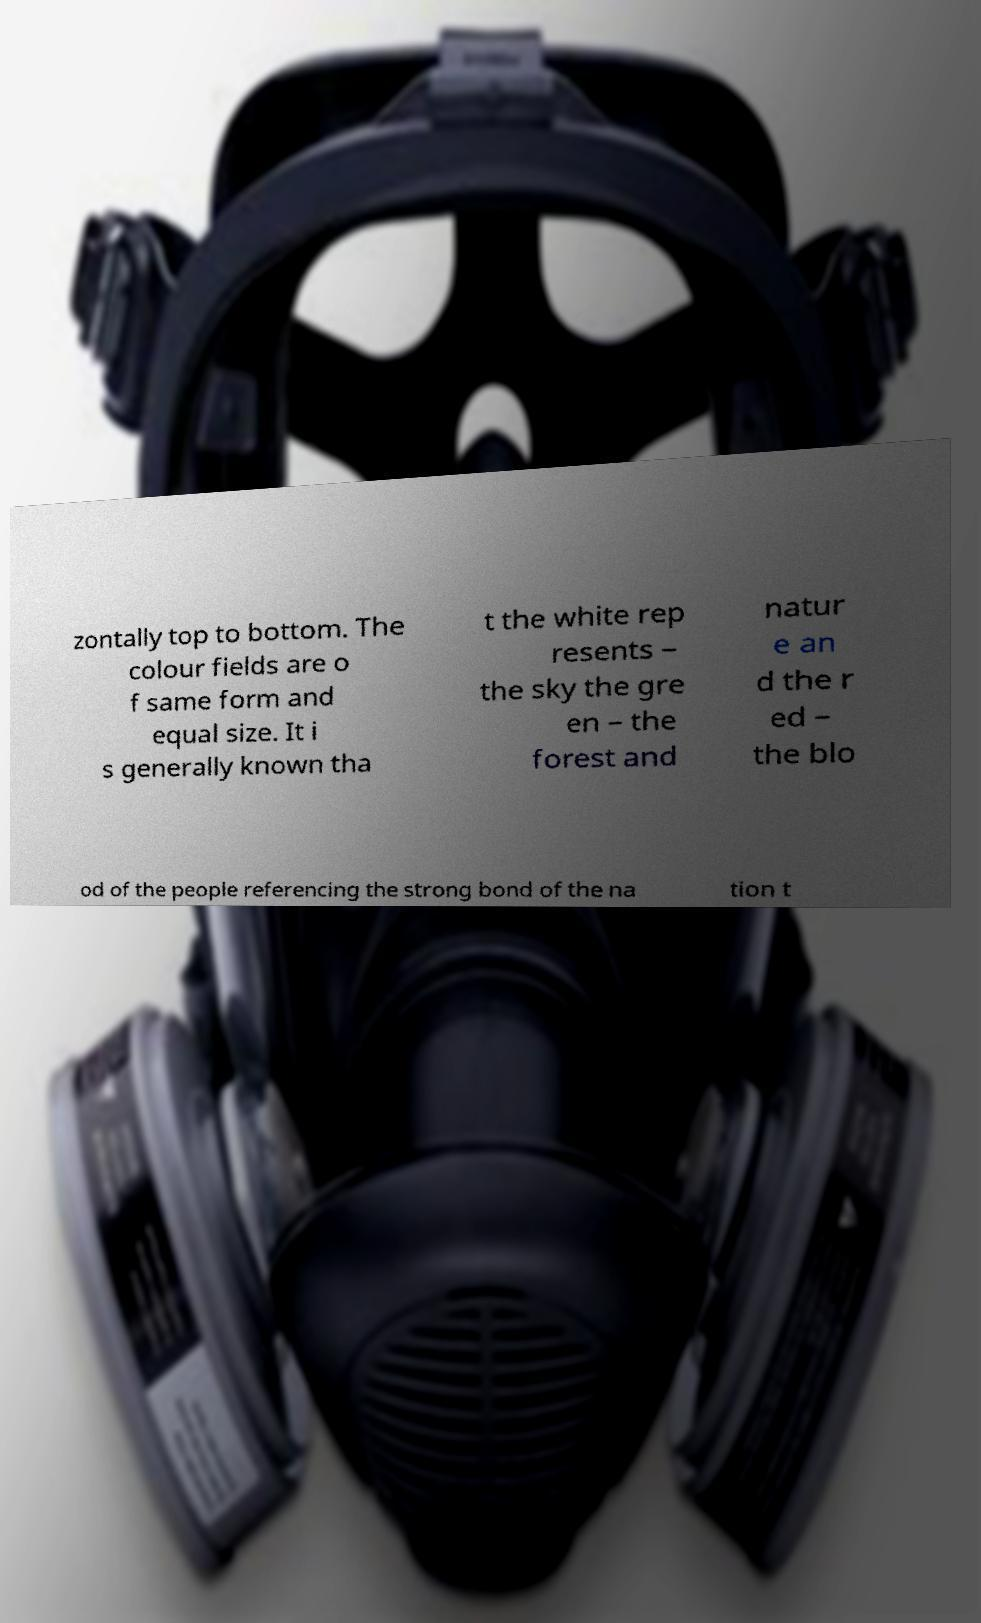There's text embedded in this image that I need extracted. Can you transcribe it verbatim? zontally top to bottom. The colour fields are o f same form and equal size. It i s generally known tha t the white rep resents – the sky the gre en – the forest and natur e an d the r ed – the blo od of the people referencing the strong bond of the na tion t 